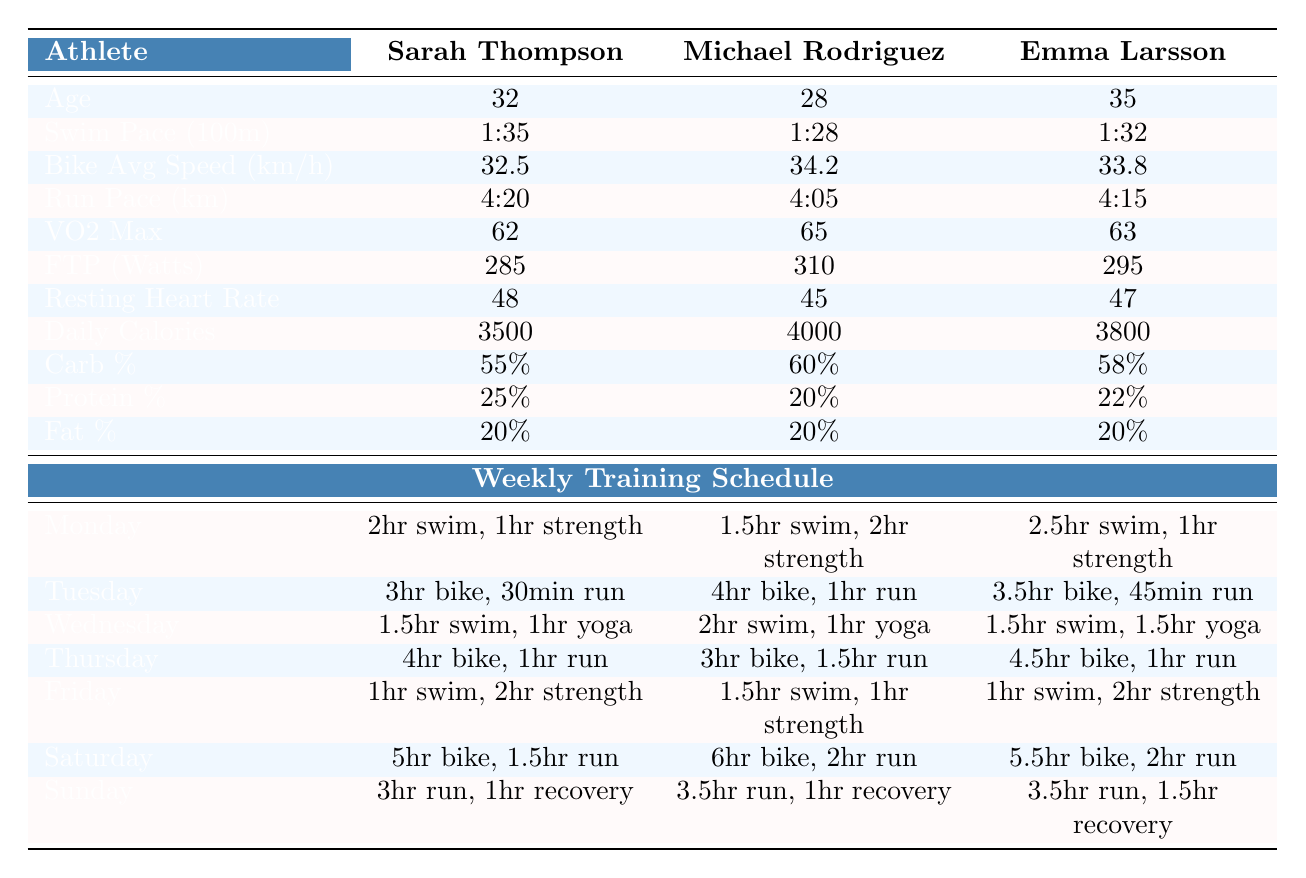What is Sarah Thompson's average bike speed? The table shows that Sarah Thompson's bike average speed is 32.5 km/h.
Answer: 32.5 km/h What is the resting heart rate of Michael Rodriguez? According to the table, Michael Rodriguez has a resting heart rate of 45 beats per minute.
Answer: 45 bpm Does Emma Larsson have a higher daily calorie intake than Sarah Thompson? The table indicates that Emma Larsson consumes 3800 calories while Sarah Thompson consumes 3500 calories; hence Emma does have a higher intake.
Answer: Yes What is the difference in VO2 Max between Sarah Thompson and Michael Rodriguez? Sarah's VO2 Max is 62 and Michael's is 65. The difference is 65 - 62 = 3.
Answer: 3 Which athlete has the best swim pace? By comparing the swim paces listed, Michael Rodriguez has the best pace at 1:28 per 100 meters.
Answer: Michael Rodriguez How many total hours does Emma Larsson train on Saturday? Emma's schedule shows 5.5 hours of biking and 2 hours of running on Saturday, totaling 5.5 + 2 = 7.5 hours.
Answer: 7.5 hours What is the average protein percentage among the three athletes? The protein percentages are 25%, 20%, and 22%. Summing these gives 25 + 20 + 22 = 67, then dividing by 3 gives an average of 67/3 = 22.33%.
Answer: 22.33% Is the average running pace for Michael Rodriguez faster than that of Sarah Thompson? Michael's run pace is 4:05, and Sarah's is 4:20; since 4:05 is less than 4:20, Michael is indeed faster.
Answer: Yes Which athlete has the highest FTP value? Comparing the FTP values in the table, Michael Rodriguez has the highest at 310 watts.
Answer: Michael Rodriguez If Sarah Thompson had 5% more daily calories, what would her new daily calorie intake be? Sarah's current intake is 3500 calories. Increasing by 5% means calculating 3500 * 1.05 = 3675 calories.
Answer: 3675 calories 